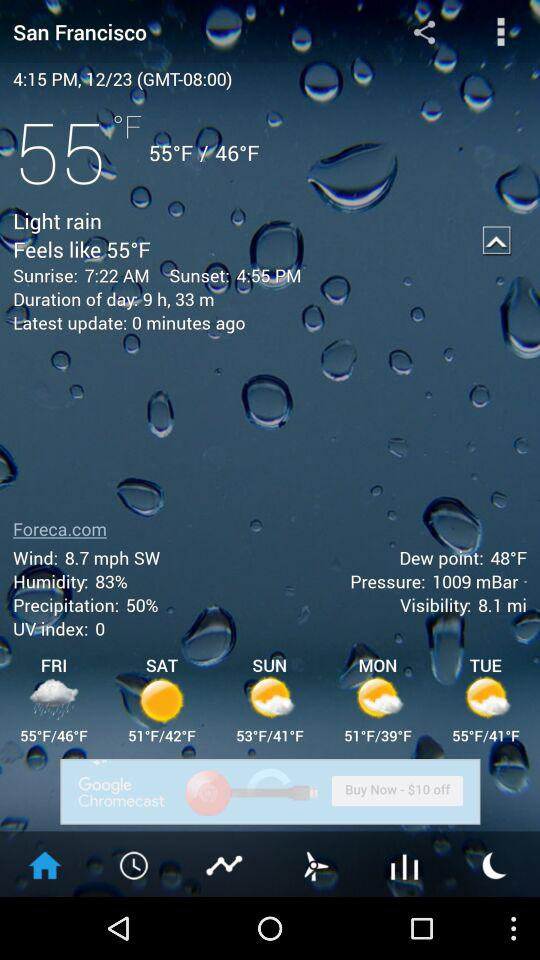How many hours of daylight are there today?
Answer the question using a single word or phrase. 9 h, 33 m 